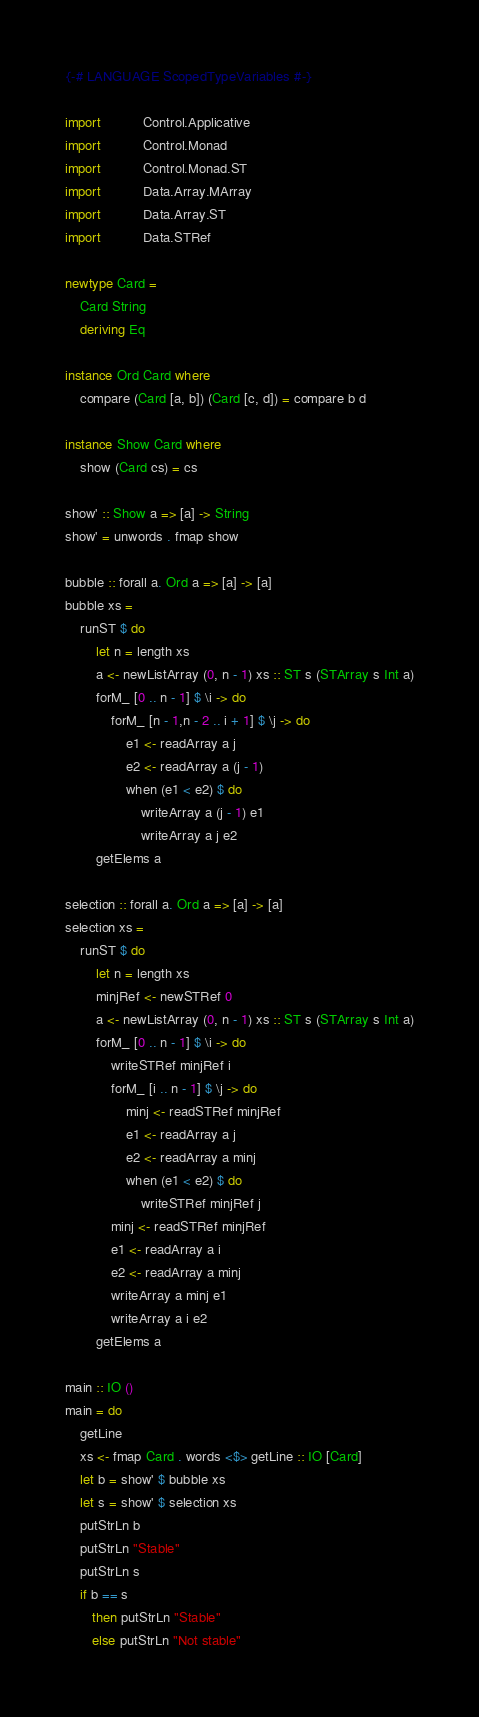Convert code to text. <code><loc_0><loc_0><loc_500><loc_500><_Haskell_>{-# LANGUAGE ScopedTypeVariables #-}

import           Control.Applicative
import           Control.Monad
import           Control.Monad.ST
import           Data.Array.MArray
import           Data.Array.ST
import           Data.STRef

newtype Card =
    Card String
    deriving Eq

instance Ord Card where
    compare (Card [a, b]) (Card [c, d]) = compare b d

instance Show Card where
    show (Card cs) = cs

show' :: Show a => [a] -> String
show' = unwords . fmap show

bubble :: forall a. Ord a => [a] -> [a]
bubble xs =
    runST $ do
        let n = length xs
        a <- newListArray (0, n - 1) xs :: ST s (STArray s Int a)
        forM_ [0 .. n - 1] $ \i -> do
            forM_ [n - 1,n - 2 .. i + 1] $ \j -> do
                e1 <- readArray a j
                e2 <- readArray a (j - 1)
                when (e1 < e2) $ do
                    writeArray a (j - 1) e1
                    writeArray a j e2
        getElems a

selection :: forall a. Ord a => [a] -> [a]
selection xs =
    runST $ do
        let n = length xs
        minjRef <- newSTRef 0
        a <- newListArray (0, n - 1) xs :: ST s (STArray s Int a)
        forM_ [0 .. n - 1] $ \i -> do
            writeSTRef minjRef i
            forM_ [i .. n - 1] $ \j -> do
                minj <- readSTRef minjRef
                e1 <- readArray a j
                e2 <- readArray a minj
                when (e1 < e2) $ do
                    writeSTRef minjRef j
            minj <- readSTRef minjRef
            e1 <- readArray a i
            e2 <- readArray a minj
            writeArray a minj e1
            writeArray a i e2
        getElems a

main :: IO ()
main = do
    getLine
    xs <- fmap Card . words <$> getLine :: IO [Card]
    let b = show' $ bubble xs
    let s = show' $ selection xs
    putStrLn b
    putStrLn "Stable"
    putStrLn s
    if b == s
       then putStrLn "Stable"
       else putStrLn "Not stable"

</code> 